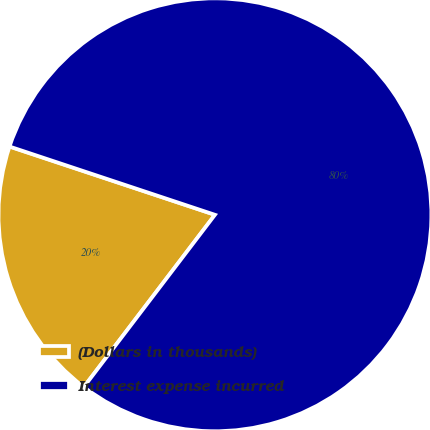Convert chart. <chart><loc_0><loc_0><loc_500><loc_500><pie_chart><fcel>(Dollars in thousands)<fcel>Interest expense incurred<nl><fcel>19.75%<fcel>80.25%<nl></chart> 